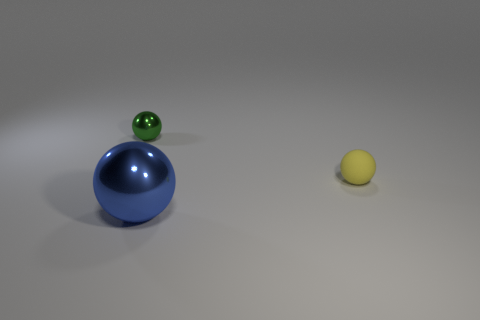Add 2 small blue metallic things. How many objects exist? 5 Subtract 0 brown blocks. How many objects are left? 3 Subtract 3 spheres. How many spheres are left? 0 Subtract all blue spheres. Subtract all red cubes. How many spheres are left? 2 Subtract all cyan cubes. How many gray spheres are left? 0 Subtract all large blue metal cylinders. Subtract all small shiny objects. How many objects are left? 2 Add 2 yellow spheres. How many yellow spheres are left? 3 Add 1 tiny green shiny cylinders. How many tiny green shiny cylinders exist? 1 Subtract all green balls. How many balls are left? 2 Subtract all metal spheres. How many spheres are left? 1 